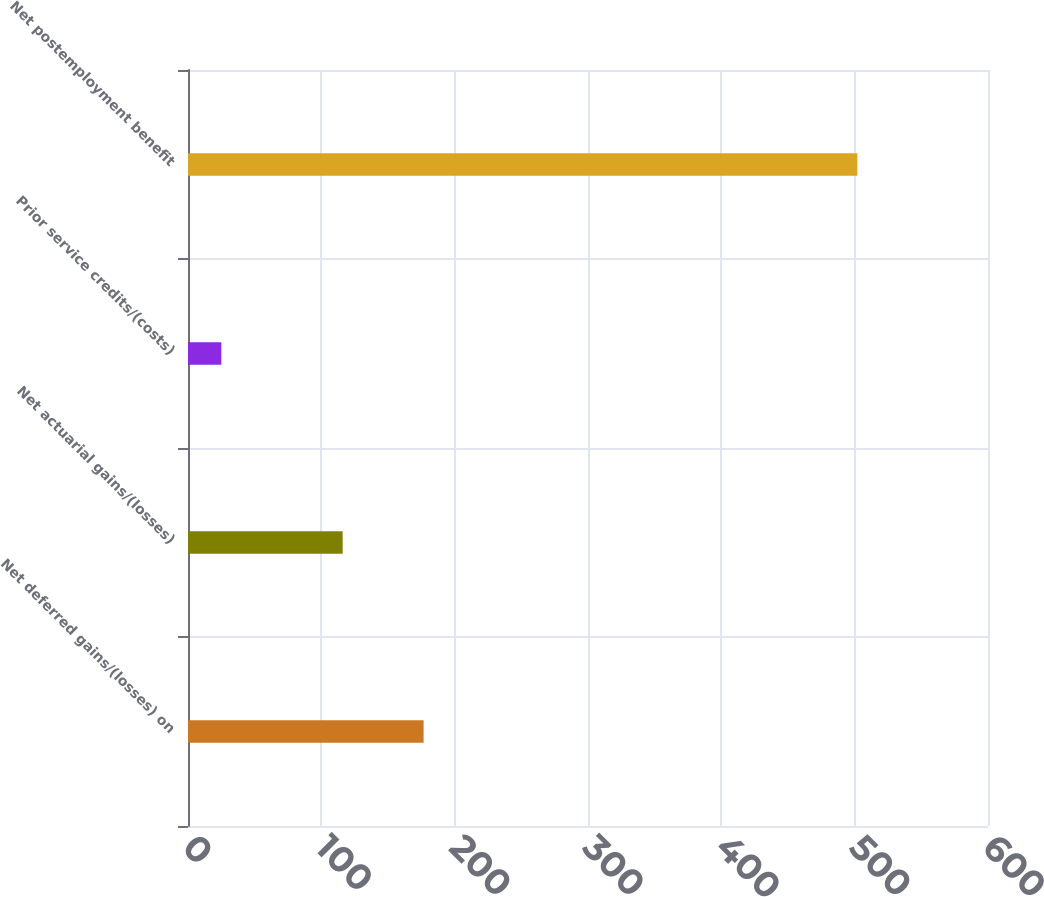<chart> <loc_0><loc_0><loc_500><loc_500><bar_chart><fcel>Net deferred gains/(losses) on<fcel>Net actuarial gains/(losses)<fcel>Prior service credits/(costs)<fcel>Net postemployment benefit<nl><fcel>176.7<fcel>116<fcel>25<fcel>502<nl></chart> 